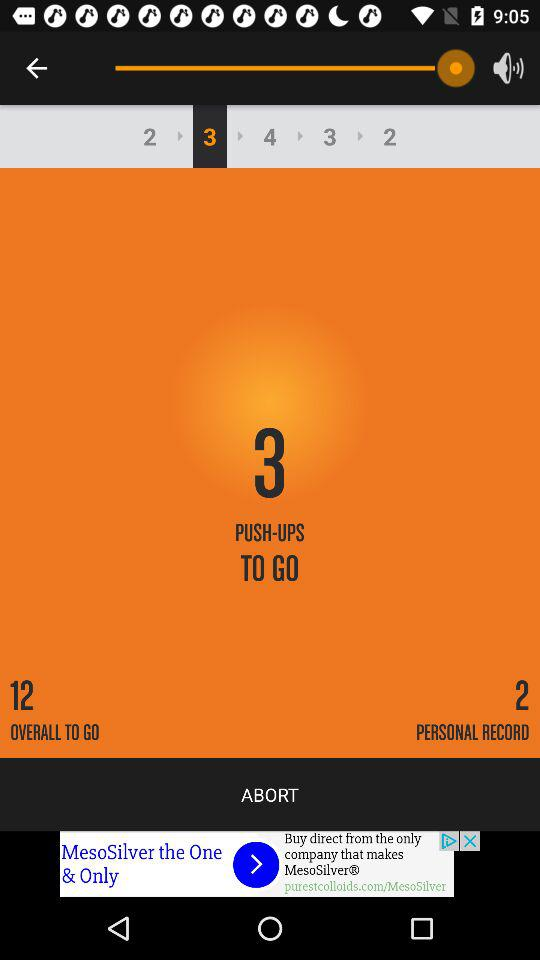What's the number of overall push-ups to go? There are 12 push-ups to go. 